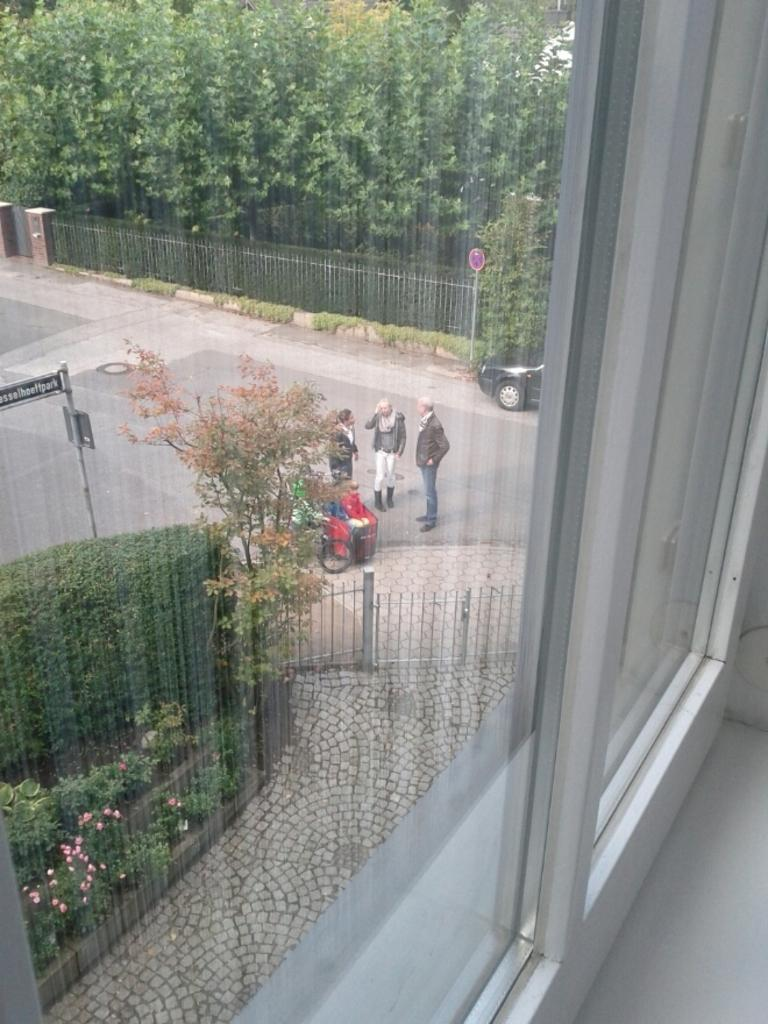What can be seen through the window in the image? People and vehicles are visible through the window in the image. What type of vegetation is present in the image? Plants, flowers, and trees are visible in the image. What type of barrier is present in the image? There is a fence in the image. What additional objects are present in the image? Boards are present in the image. What type of calendar is hanging on the fence in the image? There is no calendar present in the image; it only features a fence and boards. Can you see a cat playing with the flowers in the image? There is no cat present in the image; it only features plants, flowers, and trees. 